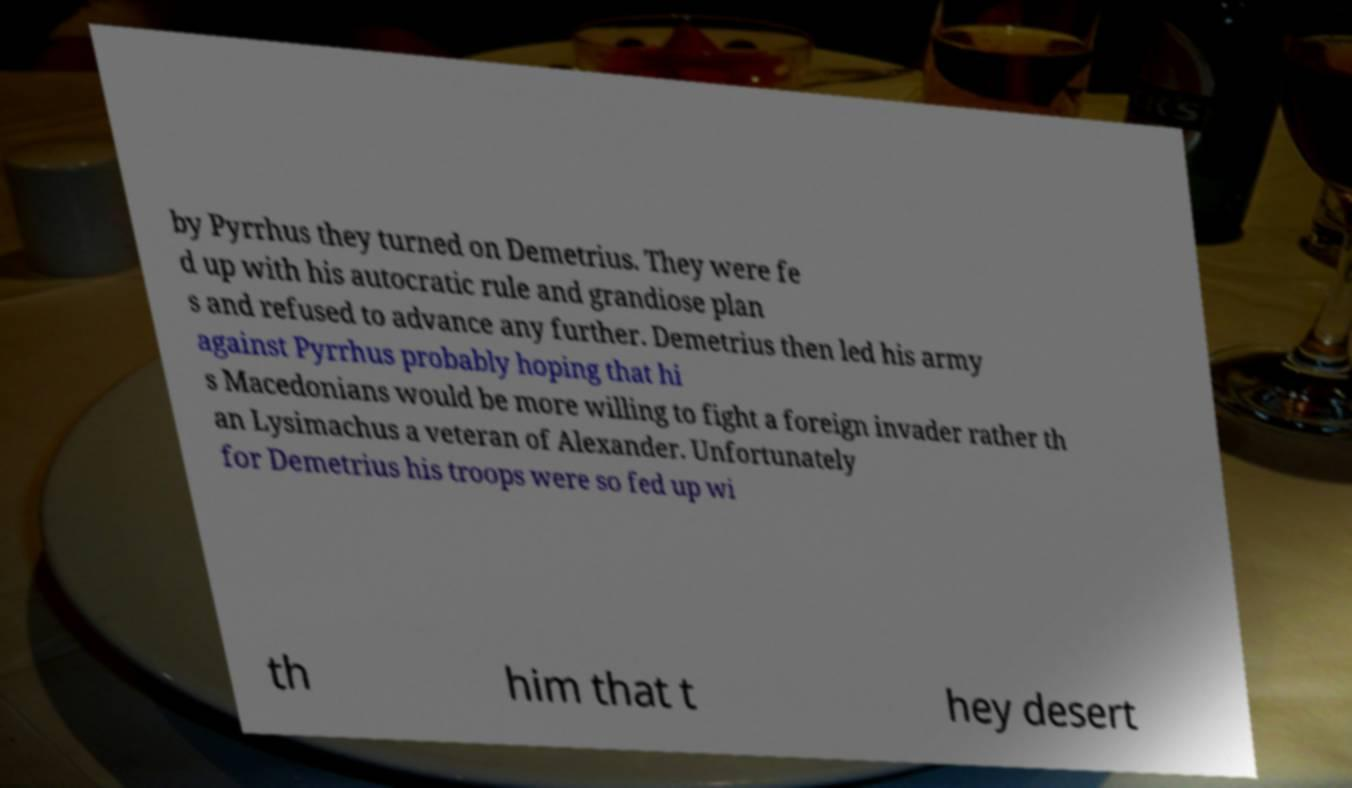I need the written content from this picture converted into text. Can you do that? by Pyrrhus they turned on Demetrius. They were fe d up with his autocratic rule and grandiose plan s and refused to advance any further. Demetrius then led his army against Pyrrhus probably hoping that hi s Macedonians would be more willing to fight a foreign invader rather th an Lysimachus a veteran of Alexander. Unfortunately for Demetrius his troops were so fed up wi th him that t hey desert 